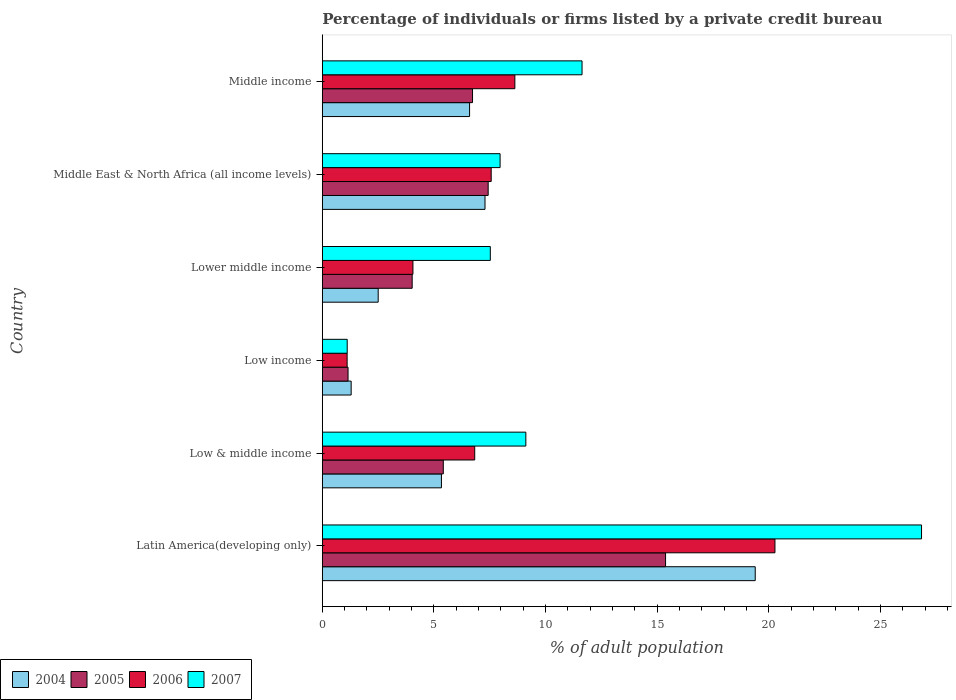How many different coloured bars are there?
Give a very brief answer. 4. How many bars are there on the 1st tick from the top?
Your answer should be very brief. 4. What is the label of the 5th group of bars from the top?
Make the answer very short. Low & middle income. What is the percentage of population listed by a private credit bureau in 2006 in Low income?
Your answer should be very brief. 1.11. Across all countries, what is the maximum percentage of population listed by a private credit bureau in 2004?
Offer a terse response. 19.39. Across all countries, what is the minimum percentage of population listed by a private credit bureau in 2006?
Provide a succinct answer. 1.11. In which country was the percentage of population listed by a private credit bureau in 2004 maximum?
Provide a succinct answer. Latin America(developing only). In which country was the percentage of population listed by a private credit bureau in 2006 minimum?
Give a very brief answer. Low income. What is the total percentage of population listed by a private credit bureau in 2005 in the graph?
Your answer should be very brief. 40.13. What is the difference between the percentage of population listed by a private credit bureau in 2004 in Latin America(developing only) and that in Middle East & North Africa (all income levels)?
Offer a terse response. 12.11. What is the difference between the percentage of population listed by a private credit bureau in 2004 in Latin America(developing only) and the percentage of population listed by a private credit bureau in 2006 in Low income?
Offer a terse response. 18.28. What is the average percentage of population listed by a private credit bureau in 2004 per country?
Your answer should be compact. 7.07. What is the difference between the percentage of population listed by a private credit bureau in 2005 and percentage of population listed by a private credit bureau in 2007 in Low & middle income?
Your answer should be very brief. -3.7. In how many countries, is the percentage of population listed by a private credit bureau in 2005 greater than 2 %?
Your answer should be very brief. 5. What is the ratio of the percentage of population listed by a private credit bureau in 2004 in Low & middle income to that in Low income?
Keep it short and to the point. 4.13. Is the difference between the percentage of population listed by a private credit bureau in 2005 in Low & middle income and Middle income greater than the difference between the percentage of population listed by a private credit bureau in 2007 in Low & middle income and Middle income?
Give a very brief answer. Yes. What is the difference between the highest and the second highest percentage of population listed by a private credit bureau in 2004?
Your answer should be compact. 12.11. What is the difference between the highest and the lowest percentage of population listed by a private credit bureau in 2006?
Your answer should be compact. 19.17. Is the sum of the percentage of population listed by a private credit bureau in 2007 in Low & middle income and Middle income greater than the maximum percentage of population listed by a private credit bureau in 2006 across all countries?
Your answer should be compact. Yes. What does the 1st bar from the top in Low income represents?
Provide a succinct answer. 2007. What does the 4th bar from the bottom in Lower middle income represents?
Your response must be concise. 2007. Are all the bars in the graph horizontal?
Provide a succinct answer. Yes. What is the difference between two consecutive major ticks on the X-axis?
Your answer should be compact. 5. Does the graph contain any zero values?
Provide a succinct answer. No. Does the graph contain grids?
Offer a terse response. No. Where does the legend appear in the graph?
Offer a very short reply. Bottom left. How many legend labels are there?
Provide a short and direct response. 4. What is the title of the graph?
Offer a terse response. Percentage of individuals or firms listed by a private credit bureau. Does "1962" appear as one of the legend labels in the graph?
Offer a terse response. No. What is the label or title of the X-axis?
Your answer should be compact. % of adult population. What is the label or title of the Y-axis?
Give a very brief answer. Country. What is the % of adult population of 2004 in Latin America(developing only)?
Give a very brief answer. 19.39. What is the % of adult population in 2005 in Latin America(developing only)?
Give a very brief answer. 15.38. What is the % of adult population in 2006 in Latin America(developing only)?
Ensure brevity in your answer.  20.28. What is the % of adult population in 2007 in Latin America(developing only)?
Give a very brief answer. 26.84. What is the % of adult population of 2004 in Low & middle income?
Offer a very short reply. 5.34. What is the % of adult population in 2005 in Low & middle income?
Keep it short and to the point. 5.42. What is the % of adult population in 2006 in Low & middle income?
Offer a very short reply. 6.83. What is the % of adult population in 2007 in Low & middle income?
Make the answer very short. 9.12. What is the % of adult population in 2004 in Low income?
Offer a very short reply. 1.29. What is the % of adult population of 2005 in Low income?
Make the answer very short. 1.15. What is the % of adult population in 2006 in Low income?
Your answer should be compact. 1.11. What is the % of adult population of 2007 in Low income?
Provide a succinct answer. 1.11. What is the % of adult population in 2004 in Lower middle income?
Give a very brief answer. 2.5. What is the % of adult population in 2005 in Lower middle income?
Keep it short and to the point. 4.03. What is the % of adult population in 2006 in Lower middle income?
Provide a succinct answer. 4.06. What is the % of adult population in 2007 in Lower middle income?
Offer a terse response. 7.53. What is the % of adult population of 2004 in Middle East & North Africa (all income levels)?
Provide a succinct answer. 7.29. What is the % of adult population of 2005 in Middle East & North Africa (all income levels)?
Offer a very short reply. 7.43. What is the % of adult population in 2006 in Middle East & North Africa (all income levels)?
Your response must be concise. 7.56. What is the % of adult population of 2007 in Middle East & North Africa (all income levels)?
Offer a very short reply. 7.96. What is the % of adult population of 2004 in Middle income?
Make the answer very short. 6.6. What is the % of adult population in 2005 in Middle income?
Offer a very short reply. 6.73. What is the % of adult population in 2006 in Middle income?
Provide a succinct answer. 8.62. What is the % of adult population of 2007 in Middle income?
Your response must be concise. 11.63. Across all countries, what is the maximum % of adult population in 2004?
Give a very brief answer. 19.39. Across all countries, what is the maximum % of adult population in 2005?
Ensure brevity in your answer.  15.38. Across all countries, what is the maximum % of adult population of 2006?
Your answer should be very brief. 20.28. Across all countries, what is the maximum % of adult population of 2007?
Keep it short and to the point. 26.84. Across all countries, what is the minimum % of adult population of 2004?
Make the answer very short. 1.29. Across all countries, what is the minimum % of adult population in 2005?
Make the answer very short. 1.15. Across all countries, what is the minimum % of adult population of 2006?
Offer a terse response. 1.11. Across all countries, what is the minimum % of adult population in 2007?
Give a very brief answer. 1.11. What is the total % of adult population of 2004 in the graph?
Make the answer very short. 42.41. What is the total % of adult population of 2005 in the graph?
Give a very brief answer. 40.13. What is the total % of adult population of 2006 in the graph?
Provide a succinct answer. 48.46. What is the total % of adult population in 2007 in the graph?
Ensure brevity in your answer.  64.2. What is the difference between the % of adult population of 2004 in Latin America(developing only) and that in Low & middle income?
Offer a very short reply. 14.06. What is the difference between the % of adult population of 2005 in Latin America(developing only) and that in Low & middle income?
Provide a succinct answer. 9.96. What is the difference between the % of adult population in 2006 in Latin America(developing only) and that in Low & middle income?
Provide a short and direct response. 13.45. What is the difference between the % of adult population of 2007 in Latin America(developing only) and that in Low & middle income?
Offer a very short reply. 17.73. What is the difference between the % of adult population of 2004 in Latin America(developing only) and that in Low income?
Your answer should be compact. 18.1. What is the difference between the % of adult population of 2005 in Latin America(developing only) and that in Low income?
Provide a succinct answer. 14.22. What is the difference between the % of adult population in 2006 in Latin America(developing only) and that in Low income?
Your answer should be very brief. 19.17. What is the difference between the % of adult population of 2007 in Latin America(developing only) and that in Low income?
Your response must be concise. 25.73. What is the difference between the % of adult population of 2004 in Latin America(developing only) and that in Lower middle income?
Make the answer very short. 16.89. What is the difference between the % of adult population in 2005 in Latin America(developing only) and that in Lower middle income?
Offer a very short reply. 11.35. What is the difference between the % of adult population in 2006 in Latin America(developing only) and that in Lower middle income?
Your answer should be very brief. 16.22. What is the difference between the % of adult population of 2007 in Latin America(developing only) and that in Lower middle income?
Offer a terse response. 19.32. What is the difference between the % of adult population in 2004 in Latin America(developing only) and that in Middle East & North Africa (all income levels)?
Offer a very short reply. 12.11. What is the difference between the % of adult population of 2005 in Latin America(developing only) and that in Middle East & North Africa (all income levels)?
Keep it short and to the point. 7.95. What is the difference between the % of adult population in 2006 in Latin America(developing only) and that in Middle East & North Africa (all income levels)?
Your answer should be very brief. 12.71. What is the difference between the % of adult population in 2007 in Latin America(developing only) and that in Middle East & North Africa (all income levels)?
Your answer should be very brief. 18.88. What is the difference between the % of adult population in 2004 in Latin America(developing only) and that in Middle income?
Offer a very short reply. 12.8. What is the difference between the % of adult population in 2005 in Latin America(developing only) and that in Middle income?
Your response must be concise. 8.65. What is the difference between the % of adult population in 2006 in Latin America(developing only) and that in Middle income?
Your answer should be very brief. 11.65. What is the difference between the % of adult population in 2007 in Latin America(developing only) and that in Middle income?
Ensure brevity in your answer.  15.21. What is the difference between the % of adult population of 2004 in Low & middle income and that in Low income?
Make the answer very short. 4.04. What is the difference between the % of adult population of 2005 in Low & middle income and that in Low income?
Provide a short and direct response. 4.27. What is the difference between the % of adult population in 2006 in Low & middle income and that in Low income?
Keep it short and to the point. 5.72. What is the difference between the % of adult population in 2007 in Low & middle income and that in Low income?
Give a very brief answer. 8. What is the difference between the % of adult population of 2004 in Low & middle income and that in Lower middle income?
Offer a terse response. 2.83. What is the difference between the % of adult population of 2005 in Low & middle income and that in Lower middle income?
Provide a succinct answer. 1.39. What is the difference between the % of adult population in 2006 in Low & middle income and that in Lower middle income?
Offer a very short reply. 2.77. What is the difference between the % of adult population of 2007 in Low & middle income and that in Lower middle income?
Your response must be concise. 1.59. What is the difference between the % of adult population of 2004 in Low & middle income and that in Middle East & North Africa (all income levels)?
Give a very brief answer. -1.95. What is the difference between the % of adult population in 2005 in Low & middle income and that in Middle East & North Africa (all income levels)?
Offer a terse response. -2.01. What is the difference between the % of adult population in 2006 in Low & middle income and that in Middle East & North Africa (all income levels)?
Offer a very short reply. -0.74. What is the difference between the % of adult population of 2007 in Low & middle income and that in Middle East & North Africa (all income levels)?
Give a very brief answer. 1.15. What is the difference between the % of adult population of 2004 in Low & middle income and that in Middle income?
Make the answer very short. -1.26. What is the difference between the % of adult population of 2005 in Low & middle income and that in Middle income?
Offer a very short reply. -1.31. What is the difference between the % of adult population of 2006 in Low & middle income and that in Middle income?
Give a very brief answer. -1.8. What is the difference between the % of adult population of 2007 in Low & middle income and that in Middle income?
Make the answer very short. -2.52. What is the difference between the % of adult population of 2004 in Low income and that in Lower middle income?
Your answer should be very brief. -1.21. What is the difference between the % of adult population of 2005 in Low income and that in Lower middle income?
Offer a very short reply. -2.87. What is the difference between the % of adult population in 2006 in Low income and that in Lower middle income?
Keep it short and to the point. -2.95. What is the difference between the % of adult population of 2007 in Low income and that in Lower middle income?
Give a very brief answer. -6.41. What is the difference between the % of adult population in 2004 in Low income and that in Middle East & North Africa (all income levels)?
Provide a succinct answer. -6. What is the difference between the % of adult population of 2005 in Low income and that in Middle East & North Africa (all income levels)?
Your answer should be very brief. -6.28. What is the difference between the % of adult population in 2006 in Low income and that in Middle East & North Africa (all income levels)?
Your answer should be compact. -6.45. What is the difference between the % of adult population in 2007 in Low income and that in Middle East & North Africa (all income levels)?
Keep it short and to the point. -6.85. What is the difference between the % of adult population of 2004 in Low income and that in Middle income?
Ensure brevity in your answer.  -5.3. What is the difference between the % of adult population in 2005 in Low income and that in Middle income?
Your response must be concise. -5.58. What is the difference between the % of adult population in 2006 in Low income and that in Middle income?
Your answer should be very brief. -7.51. What is the difference between the % of adult population in 2007 in Low income and that in Middle income?
Offer a terse response. -10.52. What is the difference between the % of adult population of 2004 in Lower middle income and that in Middle East & North Africa (all income levels)?
Offer a very short reply. -4.79. What is the difference between the % of adult population in 2005 in Lower middle income and that in Middle East & North Africa (all income levels)?
Keep it short and to the point. -3.4. What is the difference between the % of adult population in 2006 in Lower middle income and that in Middle East & North Africa (all income levels)?
Ensure brevity in your answer.  -3.51. What is the difference between the % of adult population in 2007 in Lower middle income and that in Middle East & North Africa (all income levels)?
Keep it short and to the point. -0.44. What is the difference between the % of adult population in 2004 in Lower middle income and that in Middle income?
Your response must be concise. -4.09. What is the difference between the % of adult population of 2005 in Lower middle income and that in Middle income?
Give a very brief answer. -2.7. What is the difference between the % of adult population of 2006 in Lower middle income and that in Middle income?
Your answer should be compact. -4.57. What is the difference between the % of adult population in 2007 in Lower middle income and that in Middle income?
Give a very brief answer. -4.11. What is the difference between the % of adult population of 2004 in Middle East & North Africa (all income levels) and that in Middle income?
Your answer should be compact. 0.69. What is the difference between the % of adult population in 2005 in Middle East & North Africa (all income levels) and that in Middle income?
Ensure brevity in your answer.  0.7. What is the difference between the % of adult population in 2006 in Middle East & North Africa (all income levels) and that in Middle income?
Your answer should be very brief. -1.06. What is the difference between the % of adult population in 2007 in Middle East & North Africa (all income levels) and that in Middle income?
Provide a short and direct response. -3.67. What is the difference between the % of adult population in 2004 in Latin America(developing only) and the % of adult population in 2005 in Low & middle income?
Keep it short and to the point. 13.97. What is the difference between the % of adult population in 2004 in Latin America(developing only) and the % of adult population in 2006 in Low & middle income?
Offer a very short reply. 12.57. What is the difference between the % of adult population of 2004 in Latin America(developing only) and the % of adult population of 2007 in Low & middle income?
Your answer should be compact. 10.28. What is the difference between the % of adult population of 2005 in Latin America(developing only) and the % of adult population of 2006 in Low & middle income?
Your answer should be very brief. 8.55. What is the difference between the % of adult population in 2005 in Latin America(developing only) and the % of adult population in 2007 in Low & middle income?
Keep it short and to the point. 6.26. What is the difference between the % of adult population in 2006 in Latin America(developing only) and the % of adult population in 2007 in Low & middle income?
Keep it short and to the point. 11.16. What is the difference between the % of adult population in 2004 in Latin America(developing only) and the % of adult population in 2005 in Low income?
Offer a terse response. 18.24. What is the difference between the % of adult population in 2004 in Latin America(developing only) and the % of adult population in 2006 in Low income?
Your answer should be very brief. 18.28. What is the difference between the % of adult population in 2004 in Latin America(developing only) and the % of adult population in 2007 in Low income?
Your answer should be very brief. 18.28. What is the difference between the % of adult population of 2005 in Latin America(developing only) and the % of adult population of 2006 in Low income?
Provide a succinct answer. 14.27. What is the difference between the % of adult population of 2005 in Latin America(developing only) and the % of adult population of 2007 in Low income?
Provide a succinct answer. 14.26. What is the difference between the % of adult population of 2006 in Latin America(developing only) and the % of adult population of 2007 in Low income?
Ensure brevity in your answer.  19.16. What is the difference between the % of adult population in 2004 in Latin America(developing only) and the % of adult population in 2005 in Lower middle income?
Your answer should be compact. 15.37. What is the difference between the % of adult population of 2004 in Latin America(developing only) and the % of adult population of 2006 in Lower middle income?
Provide a succinct answer. 15.33. What is the difference between the % of adult population of 2004 in Latin America(developing only) and the % of adult population of 2007 in Lower middle income?
Make the answer very short. 11.87. What is the difference between the % of adult population in 2005 in Latin America(developing only) and the % of adult population in 2006 in Lower middle income?
Your answer should be compact. 11.32. What is the difference between the % of adult population in 2005 in Latin America(developing only) and the % of adult population in 2007 in Lower middle income?
Keep it short and to the point. 7.85. What is the difference between the % of adult population in 2006 in Latin America(developing only) and the % of adult population in 2007 in Lower middle income?
Keep it short and to the point. 12.75. What is the difference between the % of adult population in 2004 in Latin America(developing only) and the % of adult population in 2005 in Middle East & North Africa (all income levels)?
Your answer should be very brief. 11.96. What is the difference between the % of adult population in 2004 in Latin America(developing only) and the % of adult population in 2006 in Middle East & North Africa (all income levels)?
Your response must be concise. 11.83. What is the difference between the % of adult population in 2004 in Latin America(developing only) and the % of adult population in 2007 in Middle East & North Africa (all income levels)?
Provide a succinct answer. 11.43. What is the difference between the % of adult population in 2005 in Latin America(developing only) and the % of adult population in 2006 in Middle East & North Africa (all income levels)?
Your answer should be compact. 7.81. What is the difference between the % of adult population in 2005 in Latin America(developing only) and the % of adult population in 2007 in Middle East & North Africa (all income levels)?
Give a very brief answer. 7.41. What is the difference between the % of adult population in 2006 in Latin America(developing only) and the % of adult population in 2007 in Middle East & North Africa (all income levels)?
Your answer should be very brief. 12.31. What is the difference between the % of adult population of 2004 in Latin America(developing only) and the % of adult population of 2005 in Middle income?
Ensure brevity in your answer.  12.66. What is the difference between the % of adult population in 2004 in Latin America(developing only) and the % of adult population in 2006 in Middle income?
Make the answer very short. 10.77. What is the difference between the % of adult population of 2004 in Latin America(developing only) and the % of adult population of 2007 in Middle income?
Ensure brevity in your answer.  7.76. What is the difference between the % of adult population in 2005 in Latin America(developing only) and the % of adult population in 2006 in Middle income?
Your response must be concise. 6.75. What is the difference between the % of adult population in 2005 in Latin America(developing only) and the % of adult population in 2007 in Middle income?
Your answer should be very brief. 3.74. What is the difference between the % of adult population in 2006 in Latin America(developing only) and the % of adult population in 2007 in Middle income?
Ensure brevity in your answer.  8.64. What is the difference between the % of adult population in 2004 in Low & middle income and the % of adult population in 2005 in Low income?
Your answer should be compact. 4.18. What is the difference between the % of adult population of 2004 in Low & middle income and the % of adult population of 2006 in Low income?
Make the answer very short. 4.22. What is the difference between the % of adult population of 2004 in Low & middle income and the % of adult population of 2007 in Low income?
Your response must be concise. 4.22. What is the difference between the % of adult population of 2005 in Low & middle income and the % of adult population of 2006 in Low income?
Your answer should be very brief. 4.31. What is the difference between the % of adult population of 2005 in Low & middle income and the % of adult population of 2007 in Low income?
Ensure brevity in your answer.  4.3. What is the difference between the % of adult population of 2006 in Low & middle income and the % of adult population of 2007 in Low income?
Make the answer very short. 5.71. What is the difference between the % of adult population in 2004 in Low & middle income and the % of adult population in 2005 in Lower middle income?
Provide a succinct answer. 1.31. What is the difference between the % of adult population of 2004 in Low & middle income and the % of adult population of 2006 in Lower middle income?
Your answer should be compact. 1.28. What is the difference between the % of adult population of 2004 in Low & middle income and the % of adult population of 2007 in Lower middle income?
Offer a very short reply. -2.19. What is the difference between the % of adult population in 2005 in Low & middle income and the % of adult population in 2006 in Lower middle income?
Give a very brief answer. 1.36. What is the difference between the % of adult population in 2005 in Low & middle income and the % of adult population in 2007 in Lower middle income?
Your response must be concise. -2.11. What is the difference between the % of adult population in 2006 in Low & middle income and the % of adult population in 2007 in Lower middle income?
Offer a very short reply. -0.7. What is the difference between the % of adult population in 2004 in Low & middle income and the % of adult population in 2005 in Middle East & North Africa (all income levels)?
Keep it short and to the point. -2.09. What is the difference between the % of adult population of 2004 in Low & middle income and the % of adult population of 2006 in Middle East & North Africa (all income levels)?
Your answer should be very brief. -2.23. What is the difference between the % of adult population of 2004 in Low & middle income and the % of adult population of 2007 in Middle East & North Africa (all income levels)?
Offer a terse response. -2.63. What is the difference between the % of adult population in 2005 in Low & middle income and the % of adult population in 2006 in Middle East & North Africa (all income levels)?
Your answer should be compact. -2.15. What is the difference between the % of adult population in 2005 in Low & middle income and the % of adult population in 2007 in Middle East & North Africa (all income levels)?
Ensure brevity in your answer.  -2.54. What is the difference between the % of adult population in 2006 in Low & middle income and the % of adult population in 2007 in Middle East & North Africa (all income levels)?
Provide a short and direct response. -1.14. What is the difference between the % of adult population in 2004 in Low & middle income and the % of adult population in 2005 in Middle income?
Keep it short and to the point. -1.39. What is the difference between the % of adult population of 2004 in Low & middle income and the % of adult population of 2006 in Middle income?
Make the answer very short. -3.29. What is the difference between the % of adult population in 2004 in Low & middle income and the % of adult population in 2007 in Middle income?
Offer a very short reply. -6.3. What is the difference between the % of adult population of 2005 in Low & middle income and the % of adult population of 2006 in Middle income?
Your response must be concise. -3.21. What is the difference between the % of adult population in 2005 in Low & middle income and the % of adult population in 2007 in Middle income?
Offer a terse response. -6.22. What is the difference between the % of adult population of 2006 in Low & middle income and the % of adult population of 2007 in Middle income?
Make the answer very short. -4.81. What is the difference between the % of adult population of 2004 in Low income and the % of adult population of 2005 in Lower middle income?
Provide a succinct answer. -2.73. What is the difference between the % of adult population in 2004 in Low income and the % of adult population in 2006 in Lower middle income?
Offer a very short reply. -2.77. What is the difference between the % of adult population in 2004 in Low income and the % of adult population in 2007 in Lower middle income?
Your answer should be compact. -6.23. What is the difference between the % of adult population in 2005 in Low income and the % of adult population in 2006 in Lower middle income?
Provide a succinct answer. -2.91. What is the difference between the % of adult population in 2005 in Low income and the % of adult population in 2007 in Lower middle income?
Offer a very short reply. -6.37. What is the difference between the % of adult population of 2006 in Low income and the % of adult population of 2007 in Lower middle income?
Offer a very short reply. -6.41. What is the difference between the % of adult population in 2004 in Low income and the % of adult population in 2005 in Middle East & North Africa (all income levels)?
Offer a very short reply. -6.14. What is the difference between the % of adult population of 2004 in Low income and the % of adult population of 2006 in Middle East & North Africa (all income levels)?
Give a very brief answer. -6.27. What is the difference between the % of adult population of 2004 in Low income and the % of adult population of 2007 in Middle East & North Africa (all income levels)?
Give a very brief answer. -6.67. What is the difference between the % of adult population in 2005 in Low income and the % of adult population in 2006 in Middle East & North Africa (all income levels)?
Provide a succinct answer. -6.41. What is the difference between the % of adult population in 2005 in Low income and the % of adult population in 2007 in Middle East & North Africa (all income levels)?
Your answer should be compact. -6.81. What is the difference between the % of adult population of 2006 in Low income and the % of adult population of 2007 in Middle East & North Africa (all income levels)?
Keep it short and to the point. -6.85. What is the difference between the % of adult population in 2004 in Low income and the % of adult population in 2005 in Middle income?
Your answer should be very brief. -5.44. What is the difference between the % of adult population of 2004 in Low income and the % of adult population of 2006 in Middle income?
Provide a short and direct response. -7.33. What is the difference between the % of adult population of 2004 in Low income and the % of adult population of 2007 in Middle income?
Provide a short and direct response. -10.34. What is the difference between the % of adult population in 2005 in Low income and the % of adult population in 2006 in Middle income?
Your answer should be very brief. -7.47. What is the difference between the % of adult population in 2005 in Low income and the % of adult population in 2007 in Middle income?
Your response must be concise. -10.48. What is the difference between the % of adult population in 2006 in Low income and the % of adult population in 2007 in Middle income?
Offer a terse response. -10.52. What is the difference between the % of adult population of 2004 in Lower middle income and the % of adult population of 2005 in Middle East & North Africa (all income levels)?
Your answer should be compact. -4.93. What is the difference between the % of adult population of 2004 in Lower middle income and the % of adult population of 2006 in Middle East & North Africa (all income levels)?
Give a very brief answer. -5.06. What is the difference between the % of adult population of 2004 in Lower middle income and the % of adult population of 2007 in Middle East & North Africa (all income levels)?
Offer a terse response. -5.46. What is the difference between the % of adult population of 2005 in Lower middle income and the % of adult population of 2006 in Middle East & North Africa (all income levels)?
Give a very brief answer. -3.54. What is the difference between the % of adult population of 2005 in Lower middle income and the % of adult population of 2007 in Middle East & North Africa (all income levels)?
Ensure brevity in your answer.  -3.94. What is the difference between the % of adult population in 2006 in Lower middle income and the % of adult population in 2007 in Middle East & North Africa (all income levels)?
Give a very brief answer. -3.9. What is the difference between the % of adult population in 2004 in Lower middle income and the % of adult population in 2005 in Middle income?
Offer a very short reply. -4.23. What is the difference between the % of adult population in 2004 in Lower middle income and the % of adult population in 2006 in Middle income?
Your response must be concise. -6.12. What is the difference between the % of adult population in 2004 in Lower middle income and the % of adult population in 2007 in Middle income?
Make the answer very short. -9.13. What is the difference between the % of adult population in 2005 in Lower middle income and the % of adult population in 2006 in Middle income?
Give a very brief answer. -4.6. What is the difference between the % of adult population in 2005 in Lower middle income and the % of adult population in 2007 in Middle income?
Offer a very short reply. -7.61. What is the difference between the % of adult population of 2006 in Lower middle income and the % of adult population of 2007 in Middle income?
Offer a terse response. -7.58. What is the difference between the % of adult population in 2004 in Middle East & North Africa (all income levels) and the % of adult population in 2005 in Middle income?
Ensure brevity in your answer.  0.56. What is the difference between the % of adult population in 2004 in Middle East & North Africa (all income levels) and the % of adult population in 2006 in Middle income?
Make the answer very short. -1.34. What is the difference between the % of adult population of 2004 in Middle East & North Africa (all income levels) and the % of adult population of 2007 in Middle income?
Your answer should be compact. -4.35. What is the difference between the % of adult population of 2005 in Middle East & North Africa (all income levels) and the % of adult population of 2006 in Middle income?
Keep it short and to the point. -1.2. What is the difference between the % of adult population in 2005 in Middle East & North Africa (all income levels) and the % of adult population in 2007 in Middle income?
Your response must be concise. -4.21. What is the difference between the % of adult population of 2006 in Middle East & North Africa (all income levels) and the % of adult population of 2007 in Middle income?
Provide a succinct answer. -4.07. What is the average % of adult population in 2004 per country?
Give a very brief answer. 7.07. What is the average % of adult population of 2005 per country?
Offer a terse response. 6.69. What is the average % of adult population of 2006 per country?
Your response must be concise. 8.08. What is the average % of adult population of 2007 per country?
Offer a terse response. 10.7. What is the difference between the % of adult population of 2004 and % of adult population of 2005 in Latin America(developing only)?
Offer a very short reply. 4.02. What is the difference between the % of adult population in 2004 and % of adult population in 2006 in Latin America(developing only)?
Your response must be concise. -0.88. What is the difference between the % of adult population in 2004 and % of adult population in 2007 in Latin America(developing only)?
Provide a short and direct response. -7.45. What is the difference between the % of adult population of 2005 and % of adult population of 2007 in Latin America(developing only)?
Provide a short and direct response. -11.47. What is the difference between the % of adult population of 2006 and % of adult population of 2007 in Latin America(developing only)?
Offer a terse response. -6.57. What is the difference between the % of adult population in 2004 and % of adult population in 2005 in Low & middle income?
Your response must be concise. -0.08. What is the difference between the % of adult population of 2004 and % of adult population of 2006 in Low & middle income?
Your response must be concise. -1.49. What is the difference between the % of adult population of 2004 and % of adult population of 2007 in Low & middle income?
Your answer should be very brief. -3.78. What is the difference between the % of adult population of 2005 and % of adult population of 2006 in Low & middle income?
Give a very brief answer. -1.41. What is the difference between the % of adult population in 2005 and % of adult population in 2007 in Low & middle income?
Ensure brevity in your answer.  -3.7. What is the difference between the % of adult population in 2006 and % of adult population in 2007 in Low & middle income?
Your answer should be very brief. -2.29. What is the difference between the % of adult population in 2004 and % of adult population in 2005 in Low income?
Your answer should be very brief. 0.14. What is the difference between the % of adult population in 2004 and % of adult population in 2006 in Low income?
Give a very brief answer. 0.18. What is the difference between the % of adult population in 2004 and % of adult population in 2007 in Low income?
Keep it short and to the point. 0.18. What is the difference between the % of adult population in 2005 and % of adult population in 2006 in Low income?
Keep it short and to the point. 0.04. What is the difference between the % of adult population in 2005 and % of adult population in 2007 in Low income?
Ensure brevity in your answer.  0.04. What is the difference between the % of adult population of 2006 and % of adult population of 2007 in Low income?
Provide a short and direct response. -0. What is the difference between the % of adult population in 2004 and % of adult population in 2005 in Lower middle income?
Keep it short and to the point. -1.52. What is the difference between the % of adult population of 2004 and % of adult population of 2006 in Lower middle income?
Offer a very short reply. -1.56. What is the difference between the % of adult population in 2004 and % of adult population in 2007 in Lower middle income?
Give a very brief answer. -5.02. What is the difference between the % of adult population of 2005 and % of adult population of 2006 in Lower middle income?
Ensure brevity in your answer.  -0.03. What is the difference between the % of adult population in 2006 and % of adult population in 2007 in Lower middle income?
Ensure brevity in your answer.  -3.47. What is the difference between the % of adult population of 2004 and % of adult population of 2005 in Middle East & North Africa (all income levels)?
Ensure brevity in your answer.  -0.14. What is the difference between the % of adult population in 2004 and % of adult population in 2006 in Middle East & North Africa (all income levels)?
Offer a very short reply. -0.28. What is the difference between the % of adult population in 2004 and % of adult population in 2007 in Middle East & North Africa (all income levels)?
Provide a short and direct response. -0.68. What is the difference between the % of adult population of 2005 and % of adult population of 2006 in Middle East & North Africa (all income levels)?
Provide a succinct answer. -0.14. What is the difference between the % of adult population of 2005 and % of adult population of 2007 in Middle East & North Africa (all income levels)?
Offer a terse response. -0.53. What is the difference between the % of adult population in 2006 and % of adult population in 2007 in Middle East & North Africa (all income levels)?
Offer a very short reply. -0.4. What is the difference between the % of adult population of 2004 and % of adult population of 2005 in Middle income?
Keep it short and to the point. -0.13. What is the difference between the % of adult population in 2004 and % of adult population in 2006 in Middle income?
Provide a short and direct response. -2.03. What is the difference between the % of adult population in 2004 and % of adult population in 2007 in Middle income?
Give a very brief answer. -5.04. What is the difference between the % of adult population of 2005 and % of adult population of 2006 in Middle income?
Make the answer very short. -1.9. What is the difference between the % of adult population in 2005 and % of adult population in 2007 in Middle income?
Provide a short and direct response. -4.91. What is the difference between the % of adult population of 2006 and % of adult population of 2007 in Middle income?
Provide a short and direct response. -3.01. What is the ratio of the % of adult population in 2004 in Latin America(developing only) to that in Low & middle income?
Your answer should be very brief. 3.63. What is the ratio of the % of adult population in 2005 in Latin America(developing only) to that in Low & middle income?
Provide a short and direct response. 2.84. What is the ratio of the % of adult population in 2006 in Latin America(developing only) to that in Low & middle income?
Offer a terse response. 2.97. What is the ratio of the % of adult population of 2007 in Latin America(developing only) to that in Low & middle income?
Make the answer very short. 2.94. What is the ratio of the % of adult population in 2004 in Latin America(developing only) to that in Low income?
Provide a succinct answer. 15.01. What is the ratio of the % of adult population of 2005 in Latin America(developing only) to that in Low income?
Your answer should be very brief. 13.35. What is the ratio of the % of adult population in 2006 in Latin America(developing only) to that in Low income?
Your answer should be compact. 18.26. What is the ratio of the % of adult population of 2007 in Latin America(developing only) to that in Low income?
Your response must be concise. 24.09. What is the ratio of the % of adult population of 2004 in Latin America(developing only) to that in Lower middle income?
Your response must be concise. 7.75. What is the ratio of the % of adult population of 2005 in Latin America(developing only) to that in Lower middle income?
Your answer should be compact. 3.82. What is the ratio of the % of adult population in 2006 in Latin America(developing only) to that in Lower middle income?
Give a very brief answer. 5. What is the ratio of the % of adult population of 2007 in Latin America(developing only) to that in Lower middle income?
Keep it short and to the point. 3.57. What is the ratio of the % of adult population in 2004 in Latin America(developing only) to that in Middle East & North Africa (all income levels)?
Provide a short and direct response. 2.66. What is the ratio of the % of adult population of 2005 in Latin America(developing only) to that in Middle East & North Africa (all income levels)?
Your response must be concise. 2.07. What is the ratio of the % of adult population in 2006 in Latin America(developing only) to that in Middle East & North Africa (all income levels)?
Your answer should be compact. 2.68. What is the ratio of the % of adult population in 2007 in Latin America(developing only) to that in Middle East & North Africa (all income levels)?
Keep it short and to the point. 3.37. What is the ratio of the % of adult population of 2004 in Latin America(developing only) to that in Middle income?
Your response must be concise. 2.94. What is the ratio of the % of adult population in 2005 in Latin America(developing only) to that in Middle income?
Offer a terse response. 2.29. What is the ratio of the % of adult population of 2006 in Latin America(developing only) to that in Middle income?
Make the answer very short. 2.35. What is the ratio of the % of adult population of 2007 in Latin America(developing only) to that in Middle income?
Make the answer very short. 2.31. What is the ratio of the % of adult population in 2004 in Low & middle income to that in Low income?
Your answer should be very brief. 4.13. What is the ratio of the % of adult population of 2005 in Low & middle income to that in Low income?
Give a very brief answer. 4.7. What is the ratio of the % of adult population in 2006 in Low & middle income to that in Low income?
Keep it short and to the point. 6.15. What is the ratio of the % of adult population of 2007 in Low & middle income to that in Low income?
Your answer should be compact. 8.18. What is the ratio of the % of adult population in 2004 in Low & middle income to that in Lower middle income?
Keep it short and to the point. 2.13. What is the ratio of the % of adult population of 2005 in Low & middle income to that in Lower middle income?
Your response must be concise. 1.35. What is the ratio of the % of adult population in 2006 in Low & middle income to that in Lower middle income?
Offer a terse response. 1.68. What is the ratio of the % of adult population in 2007 in Low & middle income to that in Lower middle income?
Your answer should be very brief. 1.21. What is the ratio of the % of adult population of 2004 in Low & middle income to that in Middle East & North Africa (all income levels)?
Your response must be concise. 0.73. What is the ratio of the % of adult population of 2005 in Low & middle income to that in Middle East & North Africa (all income levels)?
Make the answer very short. 0.73. What is the ratio of the % of adult population in 2006 in Low & middle income to that in Middle East & North Africa (all income levels)?
Ensure brevity in your answer.  0.9. What is the ratio of the % of adult population in 2007 in Low & middle income to that in Middle East & North Africa (all income levels)?
Give a very brief answer. 1.14. What is the ratio of the % of adult population of 2004 in Low & middle income to that in Middle income?
Make the answer very short. 0.81. What is the ratio of the % of adult population of 2005 in Low & middle income to that in Middle income?
Your answer should be compact. 0.81. What is the ratio of the % of adult population in 2006 in Low & middle income to that in Middle income?
Provide a short and direct response. 0.79. What is the ratio of the % of adult population of 2007 in Low & middle income to that in Middle income?
Ensure brevity in your answer.  0.78. What is the ratio of the % of adult population in 2004 in Low income to that in Lower middle income?
Your answer should be very brief. 0.52. What is the ratio of the % of adult population in 2005 in Low income to that in Lower middle income?
Ensure brevity in your answer.  0.29. What is the ratio of the % of adult population in 2006 in Low income to that in Lower middle income?
Provide a short and direct response. 0.27. What is the ratio of the % of adult population of 2007 in Low income to that in Lower middle income?
Keep it short and to the point. 0.15. What is the ratio of the % of adult population of 2004 in Low income to that in Middle East & North Africa (all income levels)?
Ensure brevity in your answer.  0.18. What is the ratio of the % of adult population of 2005 in Low income to that in Middle East & North Africa (all income levels)?
Your answer should be very brief. 0.15. What is the ratio of the % of adult population in 2006 in Low income to that in Middle East & North Africa (all income levels)?
Offer a very short reply. 0.15. What is the ratio of the % of adult population in 2007 in Low income to that in Middle East & North Africa (all income levels)?
Offer a very short reply. 0.14. What is the ratio of the % of adult population of 2004 in Low income to that in Middle income?
Your answer should be very brief. 0.2. What is the ratio of the % of adult population in 2005 in Low income to that in Middle income?
Ensure brevity in your answer.  0.17. What is the ratio of the % of adult population of 2006 in Low income to that in Middle income?
Keep it short and to the point. 0.13. What is the ratio of the % of adult population in 2007 in Low income to that in Middle income?
Offer a very short reply. 0.1. What is the ratio of the % of adult population of 2004 in Lower middle income to that in Middle East & North Africa (all income levels)?
Your answer should be very brief. 0.34. What is the ratio of the % of adult population of 2005 in Lower middle income to that in Middle East & North Africa (all income levels)?
Offer a terse response. 0.54. What is the ratio of the % of adult population in 2006 in Lower middle income to that in Middle East & North Africa (all income levels)?
Give a very brief answer. 0.54. What is the ratio of the % of adult population in 2007 in Lower middle income to that in Middle East & North Africa (all income levels)?
Your response must be concise. 0.94. What is the ratio of the % of adult population in 2004 in Lower middle income to that in Middle income?
Provide a succinct answer. 0.38. What is the ratio of the % of adult population of 2005 in Lower middle income to that in Middle income?
Make the answer very short. 0.6. What is the ratio of the % of adult population in 2006 in Lower middle income to that in Middle income?
Ensure brevity in your answer.  0.47. What is the ratio of the % of adult population in 2007 in Lower middle income to that in Middle income?
Provide a short and direct response. 0.65. What is the ratio of the % of adult population of 2004 in Middle East & North Africa (all income levels) to that in Middle income?
Give a very brief answer. 1.1. What is the ratio of the % of adult population in 2005 in Middle East & North Africa (all income levels) to that in Middle income?
Provide a succinct answer. 1.1. What is the ratio of the % of adult population of 2006 in Middle East & North Africa (all income levels) to that in Middle income?
Your answer should be compact. 0.88. What is the ratio of the % of adult population in 2007 in Middle East & North Africa (all income levels) to that in Middle income?
Your response must be concise. 0.68. What is the difference between the highest and the second highest % of adult population in 2004?
Offer a terse response. 12.11. What is the difference between the highest and the second highest % of adult population in 2005?
Provide a short and direct response. 7.95. What is the difference between the highest and the second highest % of adult population of 2006?
Your response must be concise. 11.65. What is the difference between the highest and the second highest % of adult population of 2007?
Offer a very short reply. 15.21. What is the difference between the highest and the lowest % of adult population in 2004?
Your answer should be very brief. 18.1. What is the difference between the highest and the lowest % of adult population in 2005?
Give a very brief answer. 14.22. What is the difference between the highest and the lowest % of adult population in 2006?
Provide a short and direct response. 19.17. What is the difference between the highest and the lowest % of adult population of 2007?
Provide a succinct answer. 25.73. 